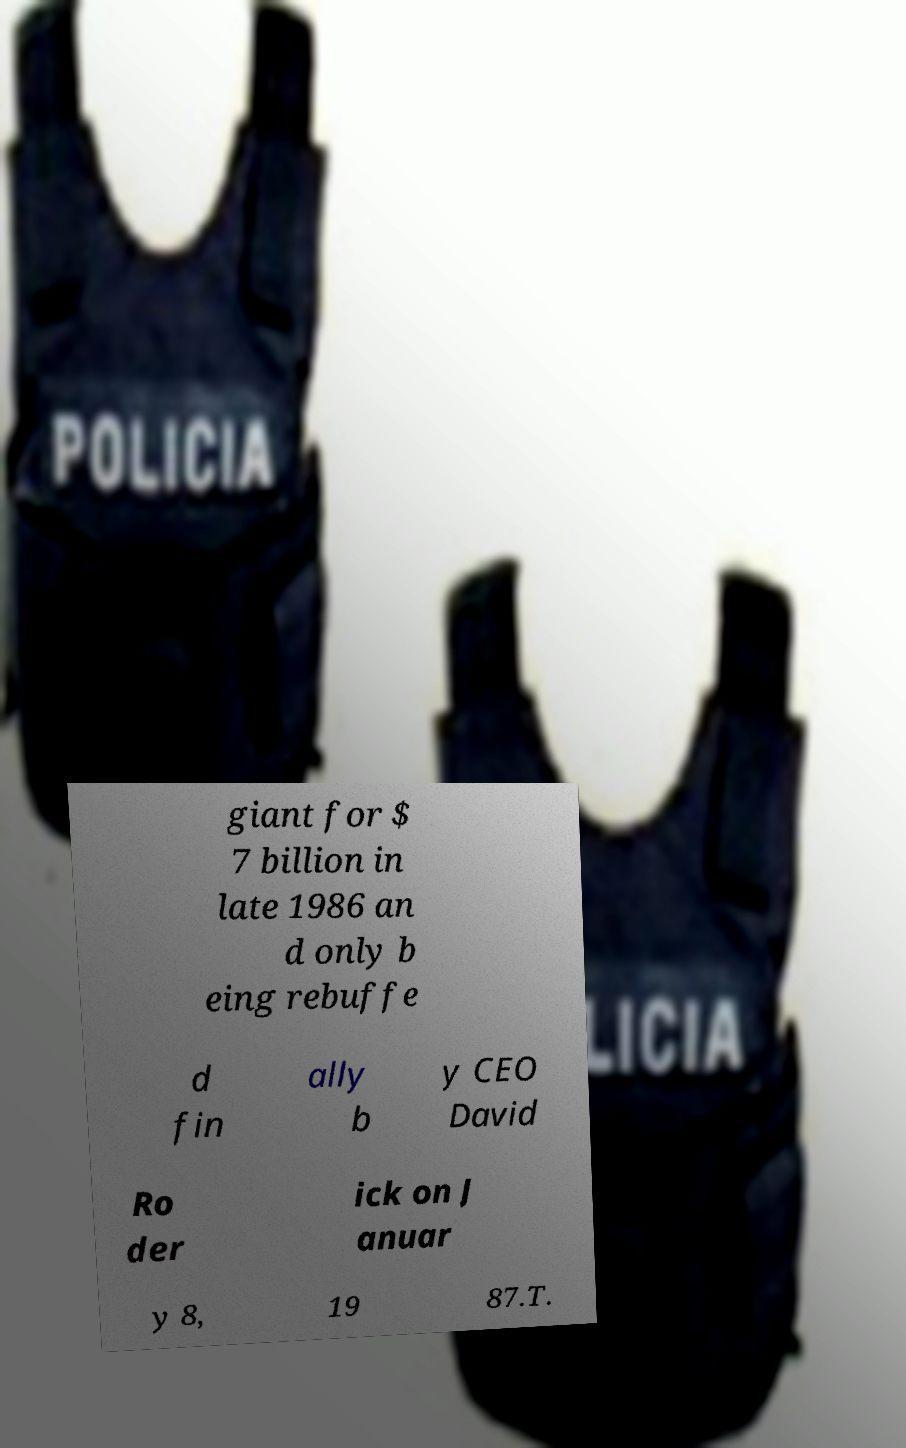There's text embedded in this image that I need extracted. Can you transcribe it verbatim? giant for $ 7 billion in late 1986 an d only b eing rebuffe d fin ally b y CEO David Ro der ick on J anuar y 8, 19 87.T. 